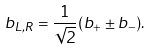<formula> <loc_0><loc_0><loc_500><loc_500>b _ { L , R } = \frac { 1 } { \sqrt { 2 } } ( b _ { + } \pm b _ { - } ) .</formula> 